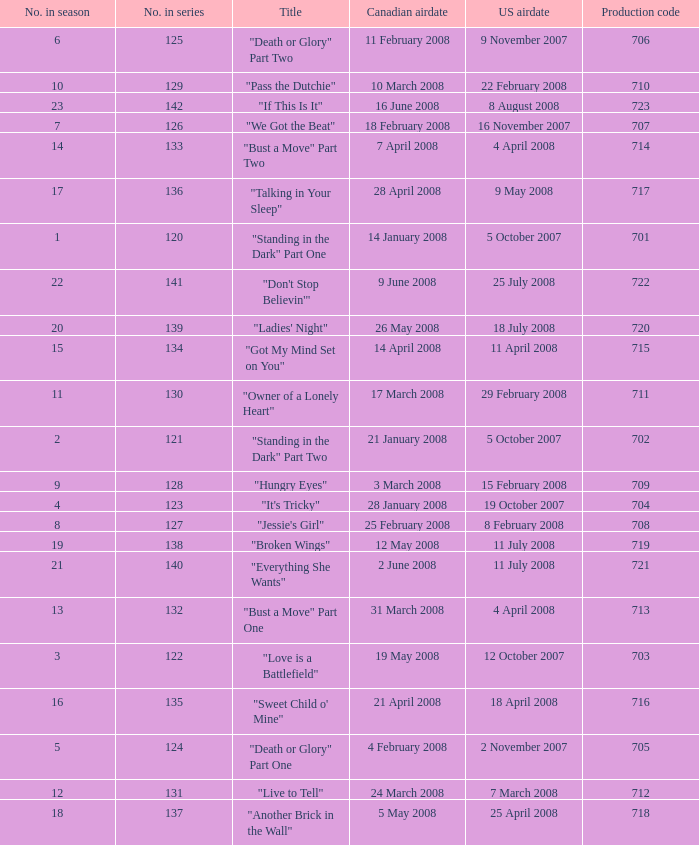Could you help me parse every detail presented in this table? {'header': ['No. in season', 'No. in series', 'Title', 'Canadian airdate', 'US airdate', 'Production code'], 'rows': [['6', '125', '"Death or Glory" Part Two', '11 February 2008', '9 November 2007', '706'], ['10', '129', '"Pass the Dutchie"', '10 March 2008', '22 February 2008', '710'], ['23', '142', '"If This Is It"', '16 June 2008', '8 August 2008', '723'], ['7', '126', '"We Got the Beat"', '18 February 2008', '16 November 2007', '707'], ['14', '133', '"Bust a Move" Part Two', '7 April 2008', '4 April 2008', '714'], ['17', '136', '"Talking in Your Sleep"', '28 April 2008', '9 May 2008', '717'], ['1', '120', '"Standing in the Dark" Part One', '14 January 2008', '5 October 2007', '701'], ['22', '141', '"Don\'t Stop Believin\'"', '9 June 2008', '25 July 2008', '722'], ['20', '139', '"Ladies\' Night"', '26 May 2008', '18 July 2008', '720'], ['15', '134', '"Got My Mind Set on You"', '14 April 2008', '11 April 2008', '715'], ['11', '130', '"Owner of a Lonely Heart"', '17 March 2008', '29 February 2008', '711'], ['2', '121', '"Standing in the Dark" Part Two', '21 January 2008', '5 October 2007', '702'], ['9', '128', '"Hungry Eyes"', '3 March 2008', '15 February 2008', '709'], ['4', '123', '"It\'s Tricky"', '28 January 2008', '19 October 2007', '704'], ['8', '127', '"Jessie\'s Girl"', '25 February 2008', '8 February 2008', '708'], ['19', '138', '"Broken Wings"', '12 May 2008', '11 July 2008', '719'], ['21', '140', '"Everything She Wants"', '2 June 2008', '11 July 2008', '721'], ['13', '132', '"Bust a Move" Part One', '31 March 2008', '4 April 2008', '713'], ['3', '122', '"Love is a Battlefield"', '19 May 2008', '12 October 2007', '703'], ['16', '135', '"Sweet Child o\' Mine"', '21 April 2008', '18 April 2008', '716'], ['5', '124', '"Death or Glory" Part One', '4 February 2008', '2 November 2007', '705'], ['12', '131', '"Live to Tell"', '24 March 2008', '7 March 2008', '712'], ['18', '137', '"Another Brick in the Wall"', '5 May 2008', '25 April 2008', '718']]} The U.S. airdate of 4 april 2008 had a production code of what? 714.0. 